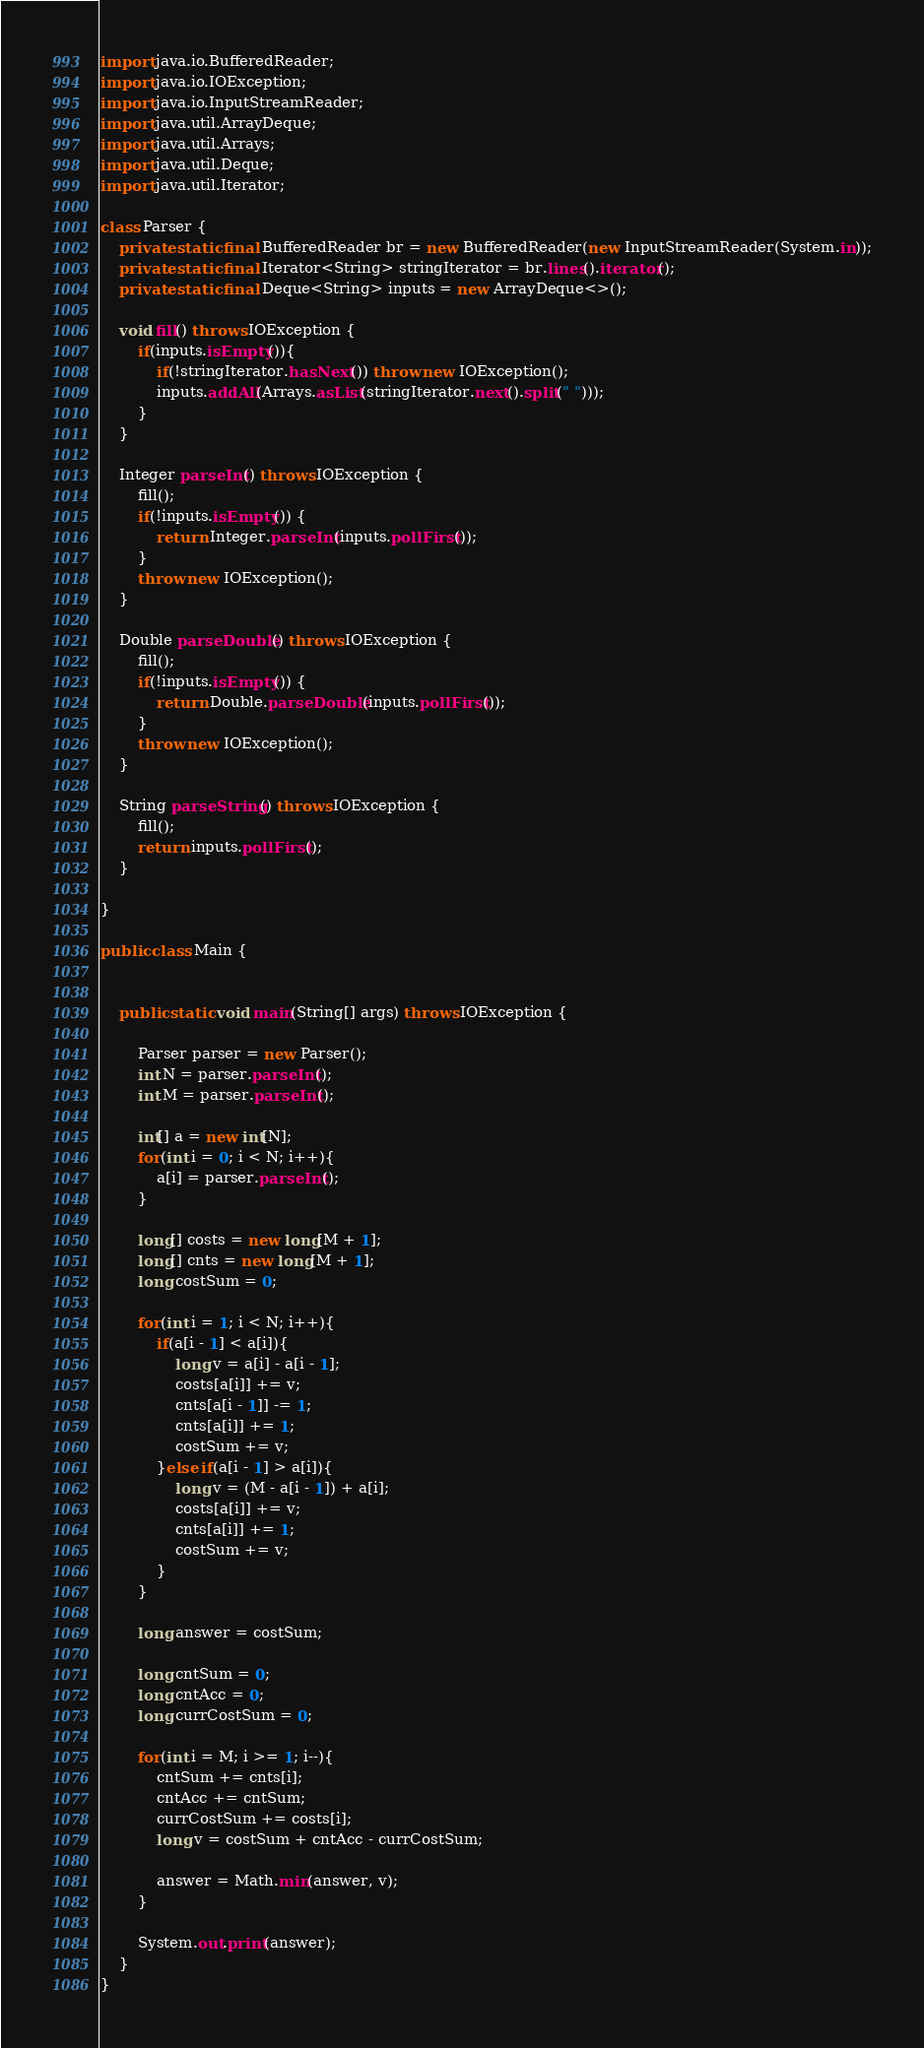Convert code to text. <code><loc_0><loc_0><loc_500><loc_500><_Java_>import java.io.BufferedReader;
import java.io.IOException;
import java.io.InputStreamReader;
import java.util.ArrayDeque;
import java.util.Arrays;
import java.util.Deque;
import java.util.Iterator;

class Parser {
    private static final BufferedReader br = new BufferedReader(new InputStreamReader(System.in));
    private static final Iterator<String> stringIterator = br.lines().iterator();
    private static final Deque<String> inputs = new ArrayDeque<>();

    void fill() throws IOException {
        if(inputs.isEmpty()){
            if(!stringIterator.hasNext()) throw new IOException();
            inputs.addAll(Arrays.asList(stringIterator.next().split(" ")));
        }
    }

    Integer parseInt() throws IOException {
        fill();
        if(!inputs.isEmpty()) {
            return Integer.parseInt(inputs.pollFirst());
        }
        throw new IOException();
    }

    Double parseDouble() throws IOException {
        fill();
        if(!inputs.isEmpty()) {
            return Double.parseDouble(inputs.pollFirst());
        }
        throw new IOException();
    }

    String parseString() throws IOException {
        fill();
        return inputs.pollFirst();
    }

}

public class Main {


    public static void main(String[] args) throws IOException {

        Parser parser = new Parser();
        int N = parser.parseInt();
        int M = parser.parseInt();

        int[] a = new int[N];
        for(int i = 0; i < N; i++){
            a[i] = parser.parseInt();
        }

        long[] costs = new long[M + 1];
        long[] cnts = new long[M + 1];
        long costSum = 0;

        for(int i = 1; i < N; i++){
            if(a[i - 1] < a[i]){
                long v = a[i] - a[i - 1];
                costs[a[i]] += v;
                cnts[a[i - 1]] -= 1;
                cnts[a[i]] += 1;
                costSum += v;
            }else if(a[i - 1] > a[i]){
                long v = (M - a[i - 1]) + a[i];
                costs[a[i]] += v;
                cnts[a[i]] += 1;
                costSum += v;
            }
        }

        long answer = costSum;

        long cntSum = 0;
        long cntAcc = 0;
        long currCostSum = 0;

        for(int i = M; i >= 1; i--){
            cntSum += cnts[i];
            cntAcc += cntSum;
            currCostSum += costs[i];
            long v = costSum + cntAcc - currCostSum;

            answer = Math.min(answer, v);
        }

        System.out.print(answer);
    }
}
</code> 